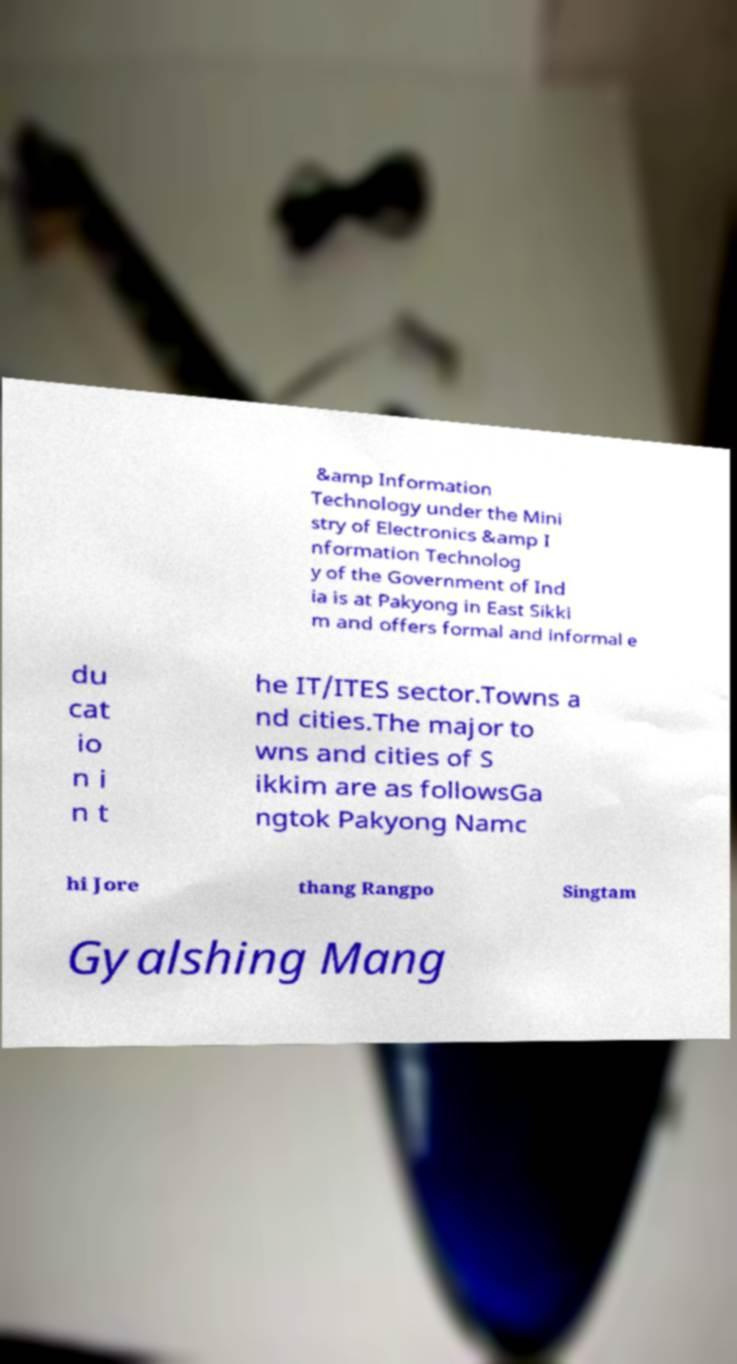For documentation purposes, I need the text within this image transcribed. Could you provide that? &amp Information Technology under the Mini stry of Electronics &amp I nformation Technolog y of the Government of Ind ia is at Pakyong in East Sikki m and offers formal and informal e du cat io n i n t he IT/ITES sector.Towns a nd cities.The major to wns and cities of S ikkim are as followsGa ngtok Pakyong Namc hi Jore thang Rangpo Singtam Gyalshing Mang 